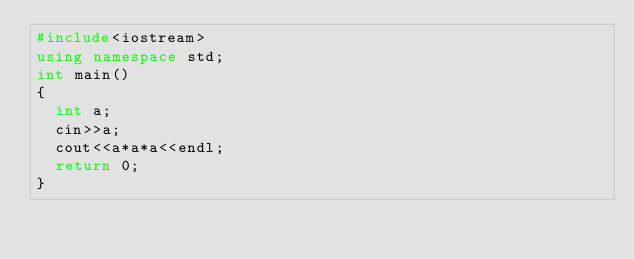Convert code to text. <code><loc_0><loc_0><loc_500><loc_500><_C++_>#include<iostream>
using namespace std;
int main()
{
  int a;
  cin>>a;
  cout<<a*a*a<<endl;
  return 0;
}

</code> 